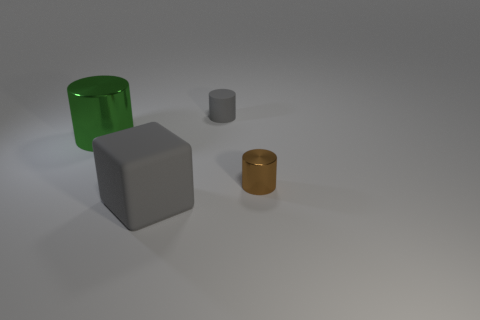What shapes are present in the image, and do they suggest any particular setting or theme? The image features a variety of geometric shapes: a cylinder, a cube, and a small circular object. There's no clear setting or theme implied by these simple shapes; they could be placeholders or objects in a minimalist or abstract composition. 